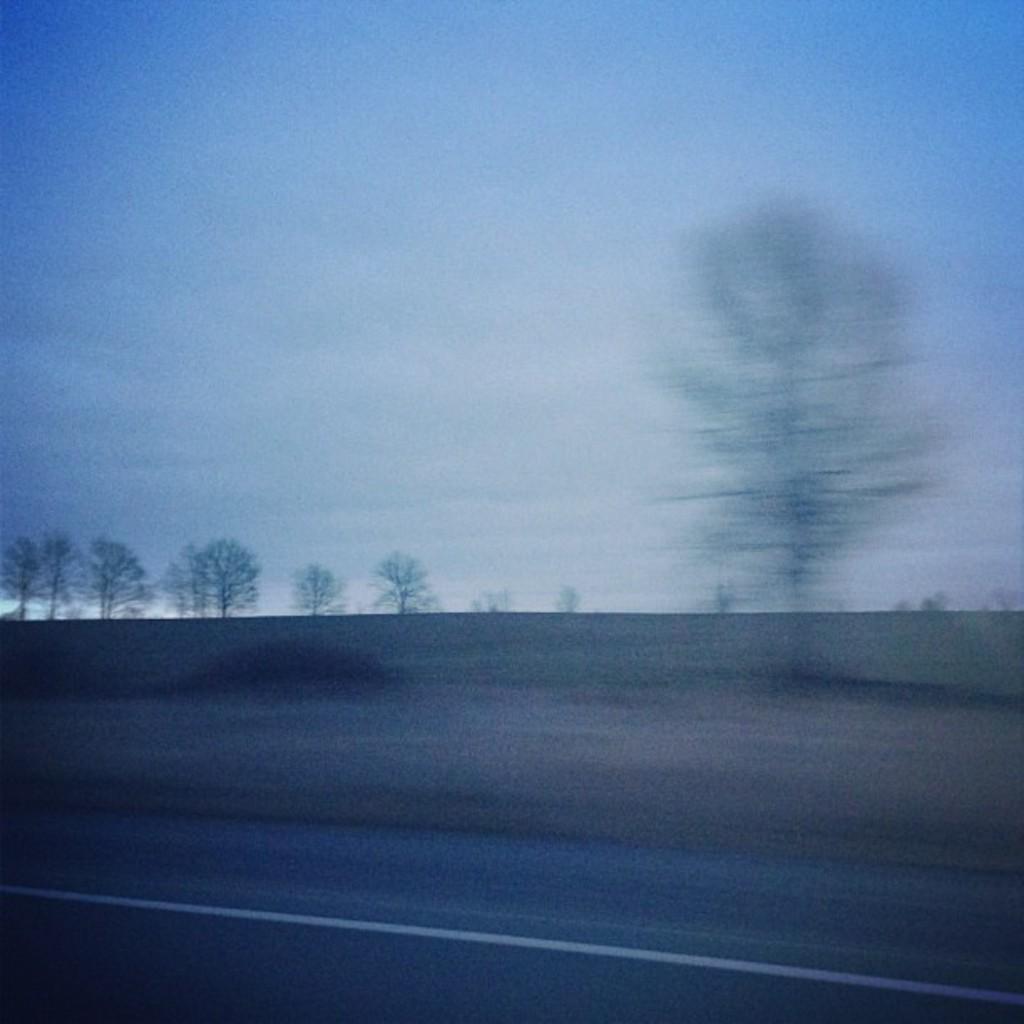In one or two sentences, can you explain what this image depicts? In front of the image there is a road. In the background of the image there are trees and sky. 